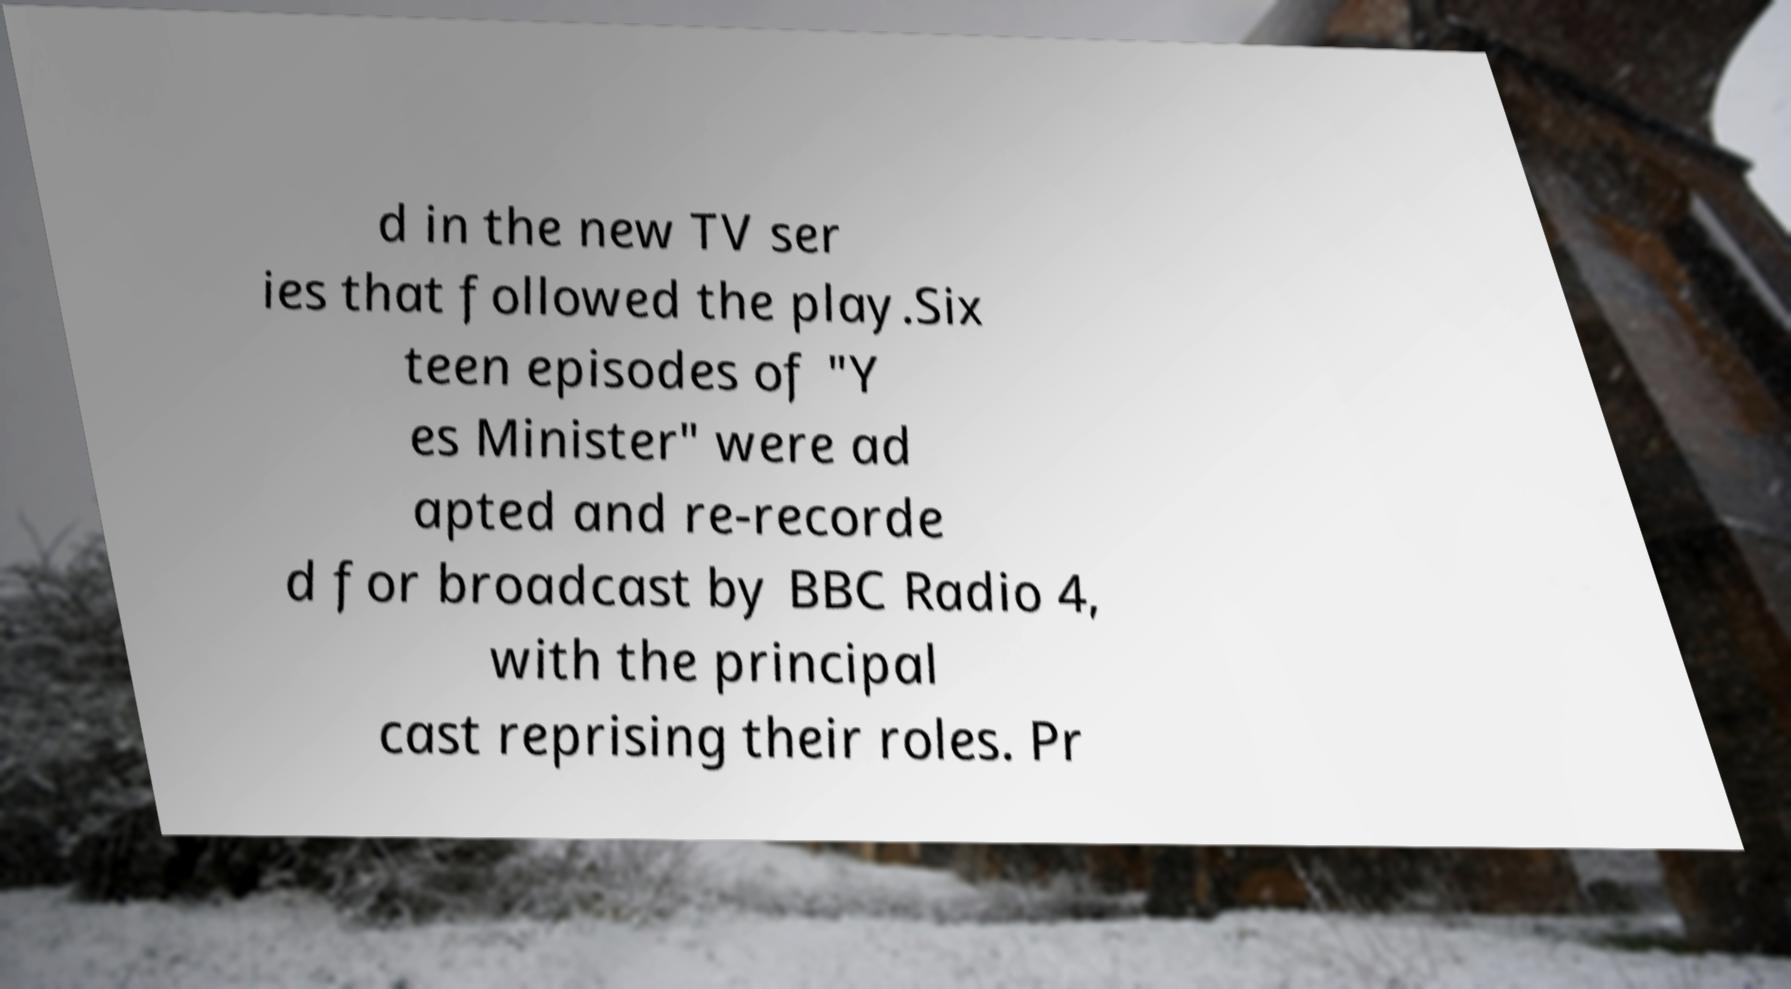Please read and relay the text visible in this image. What does it say? d in the new TV ser ies that followed the play.Six teen episodes of "Y es Minister" were ad apted and re-recorde d for broadcast by BBC Radio 4, with the principal cast reprising their roles. Pr 